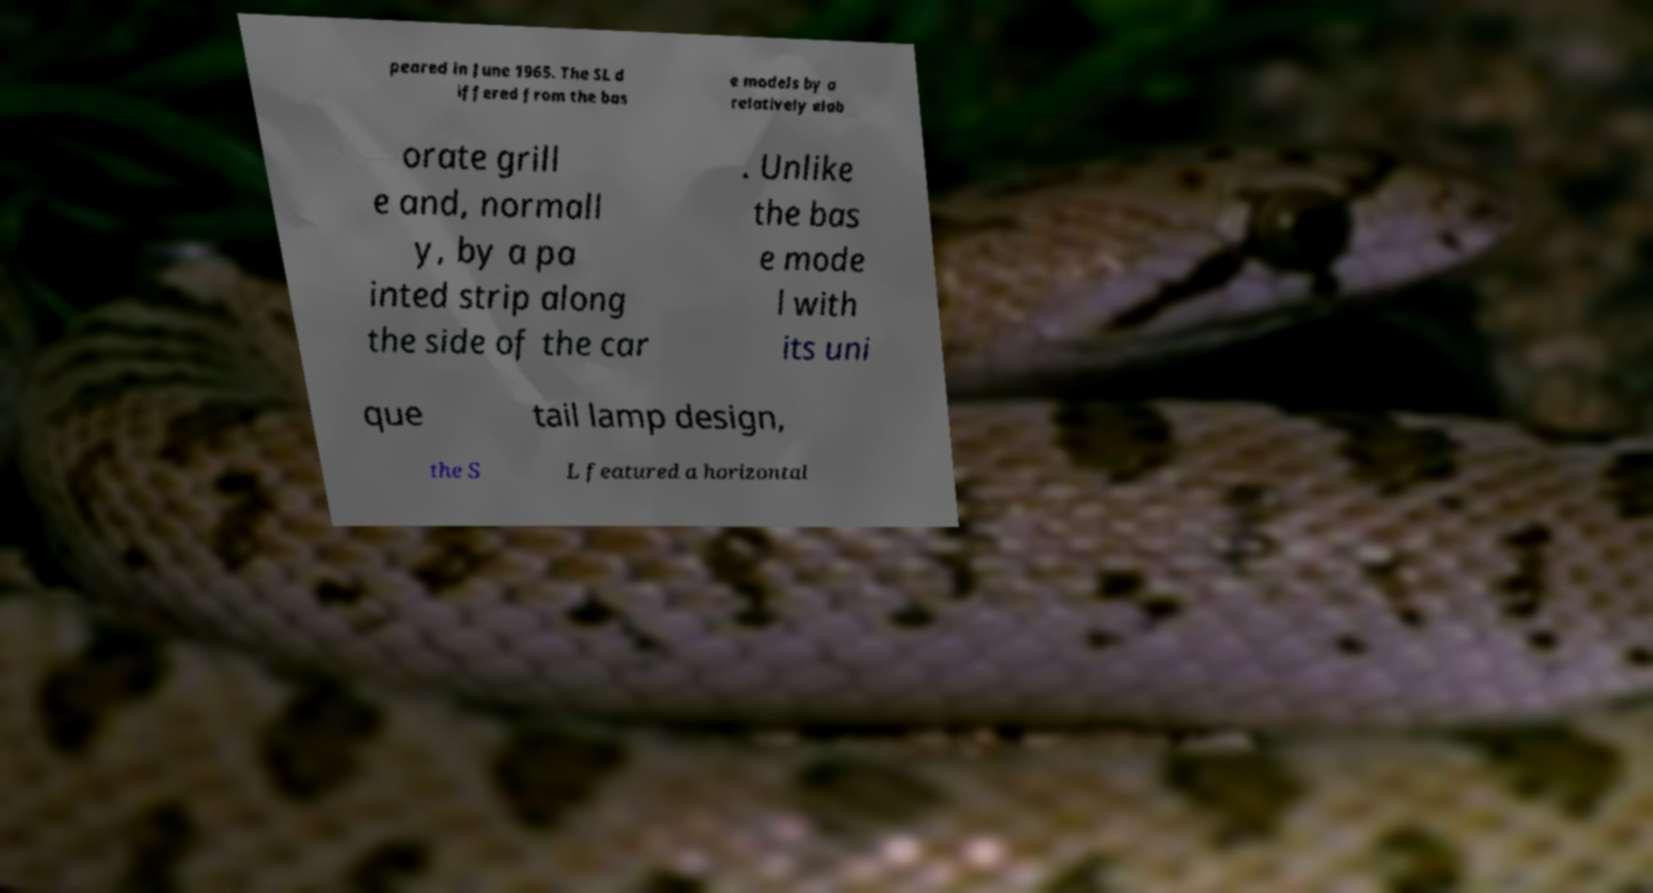Please read and relay the text visible in this image. What does it say? peared in June 1965. The SL d iffered from the bas e models by a relatively elab orate grill e and, normall y, by a pa inted strip along the side of the car . Unlike the bas e mode l with its uni que tail lamp design, the S L featured a horizontal 